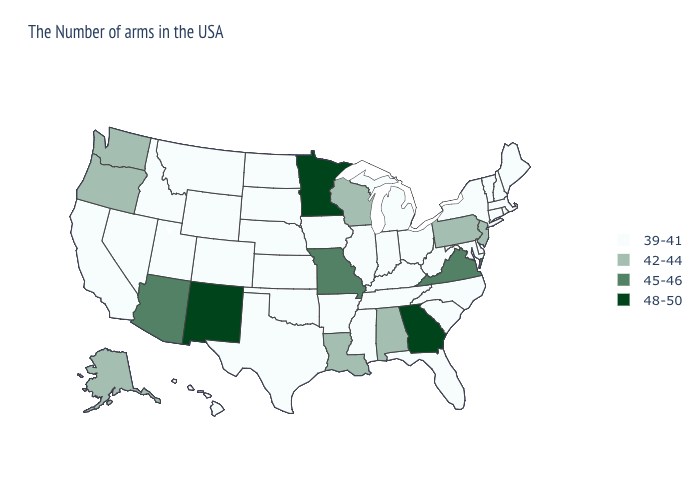What is the value of Ohio?
Be succinct. 39-41. What is the lowest value in the USA?
Quick response, please. 39-41. What is the highest value in the USA?
Keep it brief. 48-50. Does the first symbol in the legend represent the smallest category?
Quick response, please. Yes. What is the highest value in states that border Arkansas?
Short answer required. 45-46. Name the states that have a value in the range 42-44?
Give a very brief answer. New Jersey, Pennsylvania, Alabama, Wisconsin, Louisiana, Washington, Oregon, Alaska. Name the states that have a value in the range 42-44?
Short answer required. New Jersey, Pennsylvania, Alabama, Wisconsin, Louisiana, Washington, Oregon, Alaska. Which states hav the highest value in the South?
Answer briefly. Georgia. Does Connecticut have the same value as Indiana?
Concise answer only. Yes. What is the lowest value in states that border Idaho?
Quick response, please. 39-41. Name the states that have a value in the range 39-41?
Be succinct. Maine, Massachusetts, Rhode Island, New Hampshire, Vermont, Connecticut, New York, Delaware, Maryland, North Carolina, South Carolina, West Virginia, Ohio, Florida, Michigan, Kentucky, Indiana, Tennessee, Illinois, Mississippi, Arkansas, Iowa, Kansas, Nebraska, Oklahoma, Texas, South Dakota, North Dakota, Wyoming, Colorado, Utah, Montana, Idaho, Nevada, California, Hawaii. How many symbols are there in the legend?
Write a very short answer. 4. Among the states that border Minnesota , does Wisconsin have the highest value?
Short answer required. Yes. Does Georgia have the highest value in the South?
Concise answer only. Yes. Which states have the lowest value in the West?
Write a very short answer. Wyoming, Colorado, Utah, Montana, Idaho, Nevada, California, Hawaii. 